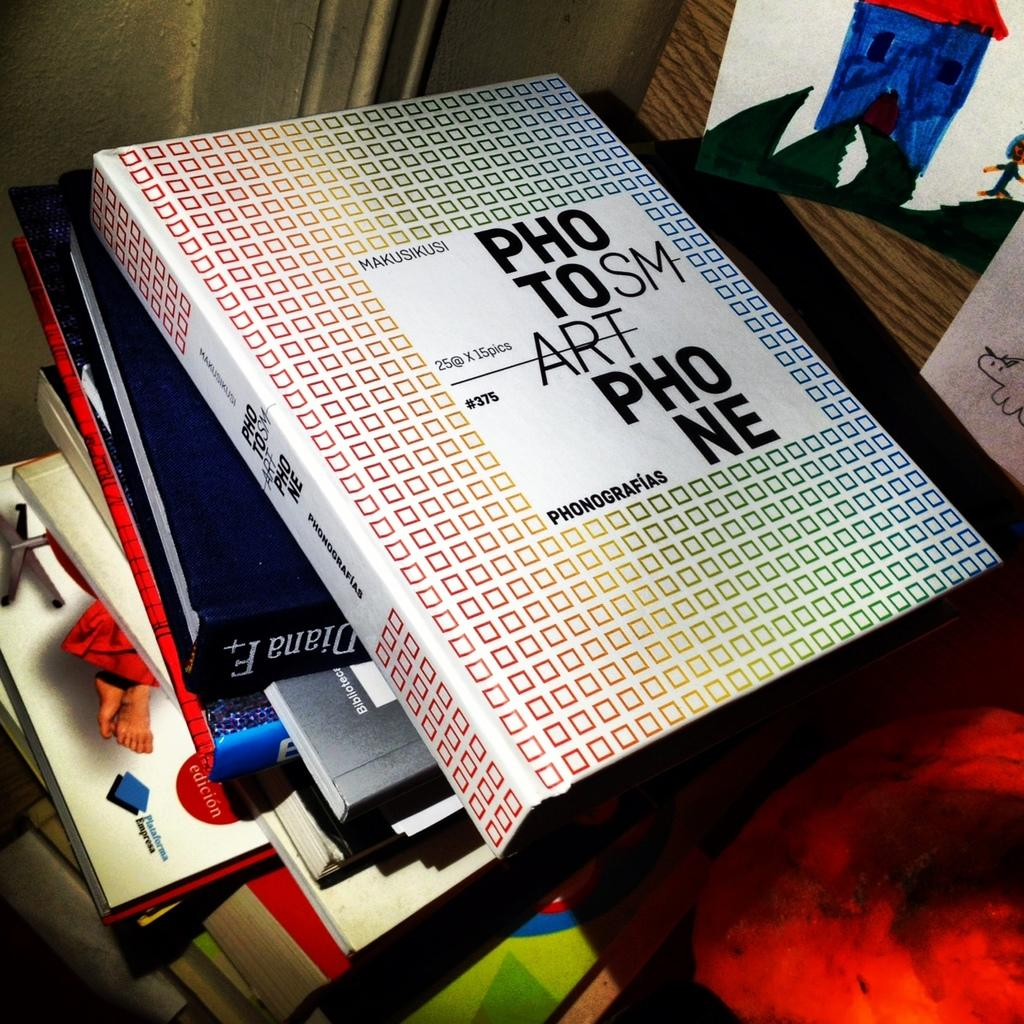Provide a one-sentence caption for the provided image. a stack of books, the top one is covered in small squares with words on it photo smart phone. 